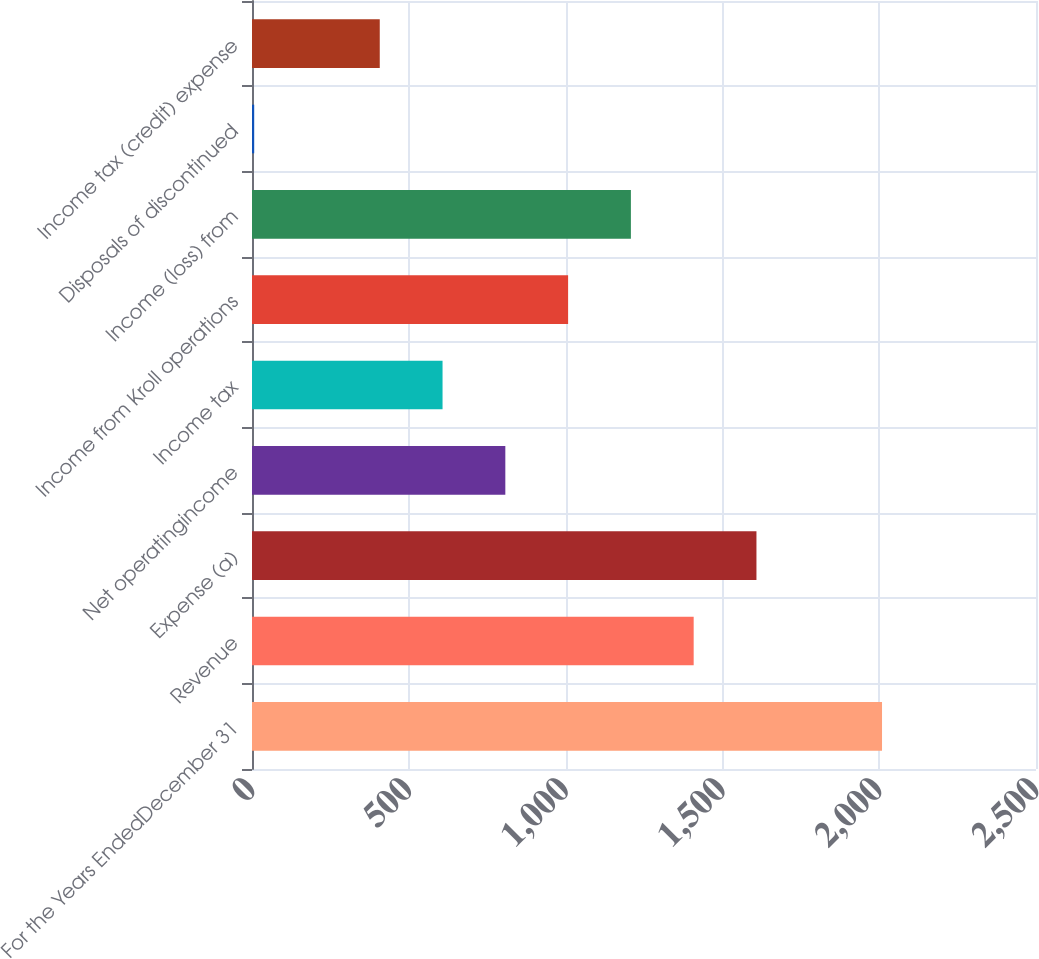<chart> <loc_0><loc_0><loc_500><loc_500><bar_chart><fcel>For the Years EndedDecember 31<fcel>Revenue<fcel>Expense (a)<fcel>Net operatingincome<fcel>Income tax<fcel>Income from Kroll operations<fcel>Income (loss) from<fcel>Disposals of discontinued<fcel>Income tax (credit) expense<nl><fcel>2009<fcel>1408.4<fcel>1608.6<fcel>807.8<fcel>607.6<fcel>1008<fcel>1208.2<fcel>7<fcel>407.4<nl></chart> 